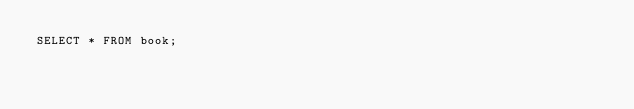Convert code to text. <code><loc_0><loc_0><loc_500><loc_500><_SQL_>SELECT * FROM book;
</code> 